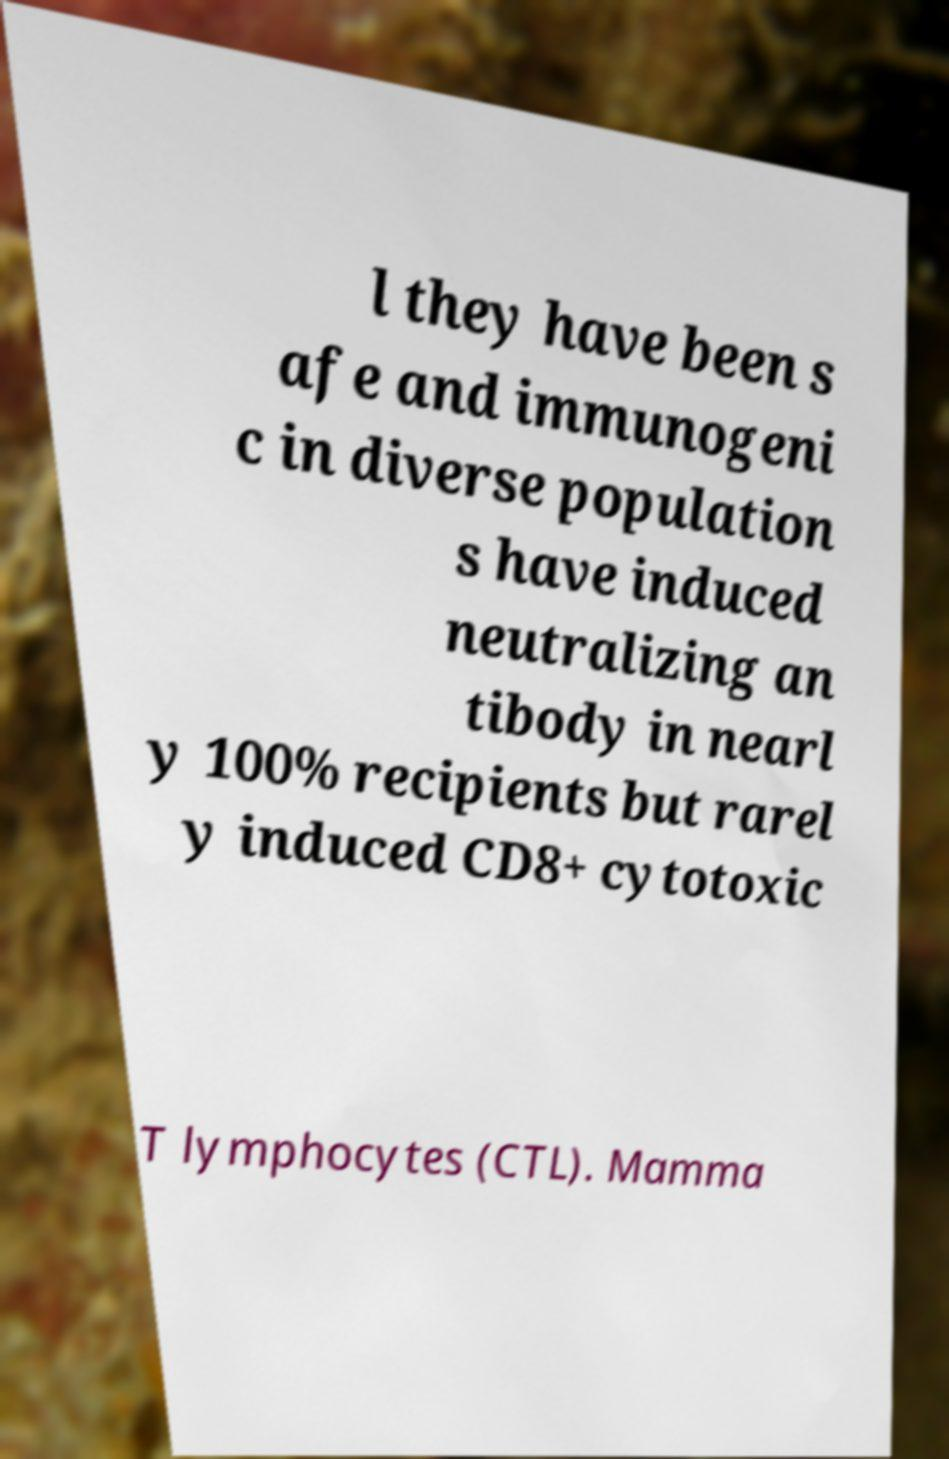Can you accurately transcribe the text from the provided image for me? l they have been s afe and immunogeni c in diverse population s have induced neutralizing an tibody in nearl y 100% recipients but rarel y induced CD8+ cytotoxic T lymphocytes (CTL). Mamma 